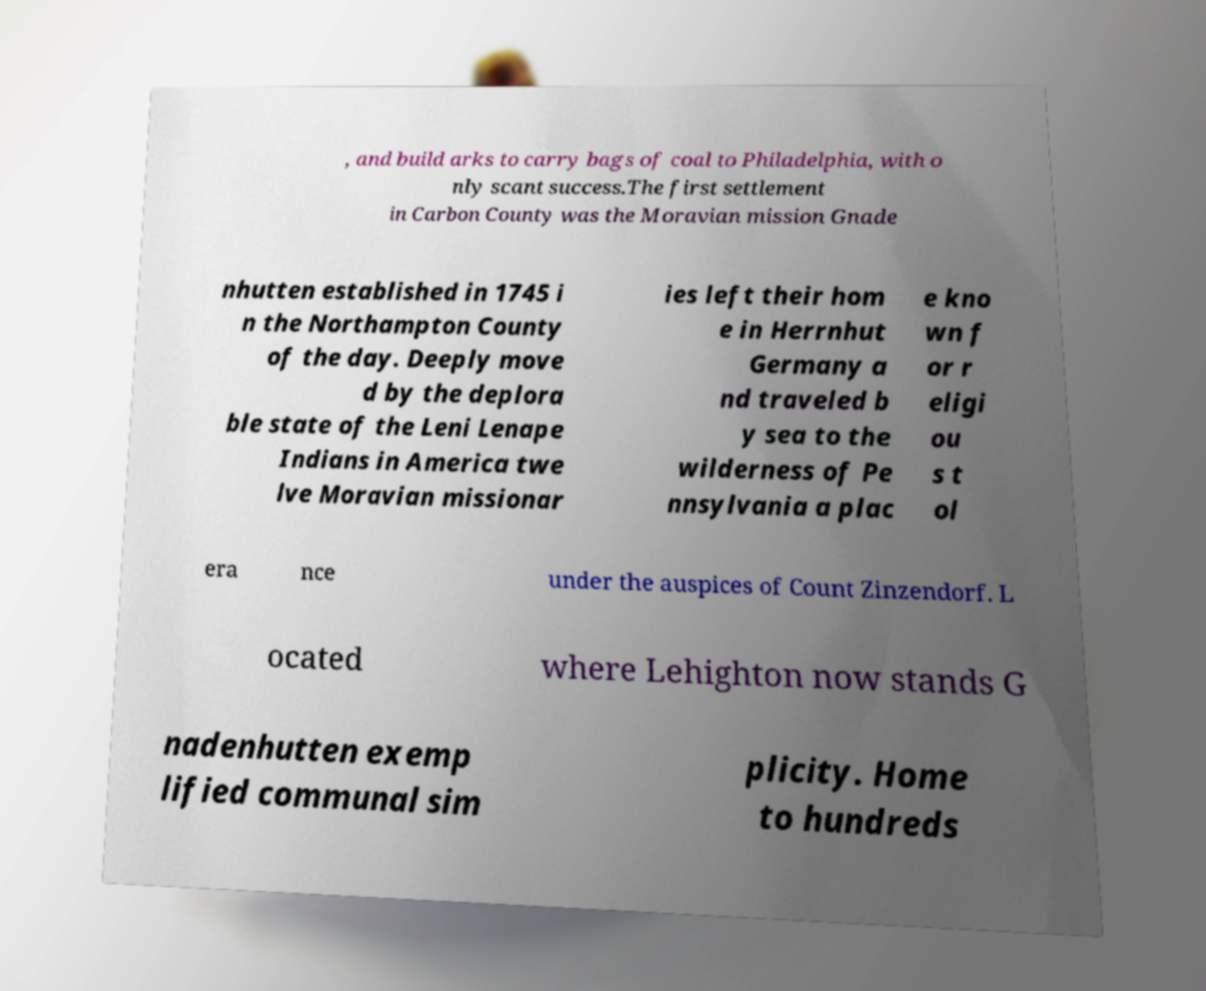Please identify and transcribe the text found in this image. , and build arks to carry bags of coal to Philadelphia, with o nly scant success.The first settlement in Carbon County was the Moravian mission Gnade nhutten established in 1745 i n the Northampton County of the day. Deeply move d by the deplora ble state of the Leni Lenape Indians in America twe lve Moravian missionar ies left their hom e in Herrnhut Germany a nd traveled b y sea to the wilderness of Pe nnsylvania a plac e kno wn f or r eligi ou s t ol era nce under the auspices of Count Zinzendorf. L ocated where Lehighton now stands G nadenhutten exemp lified communal sim plicity. Home to hundreds 